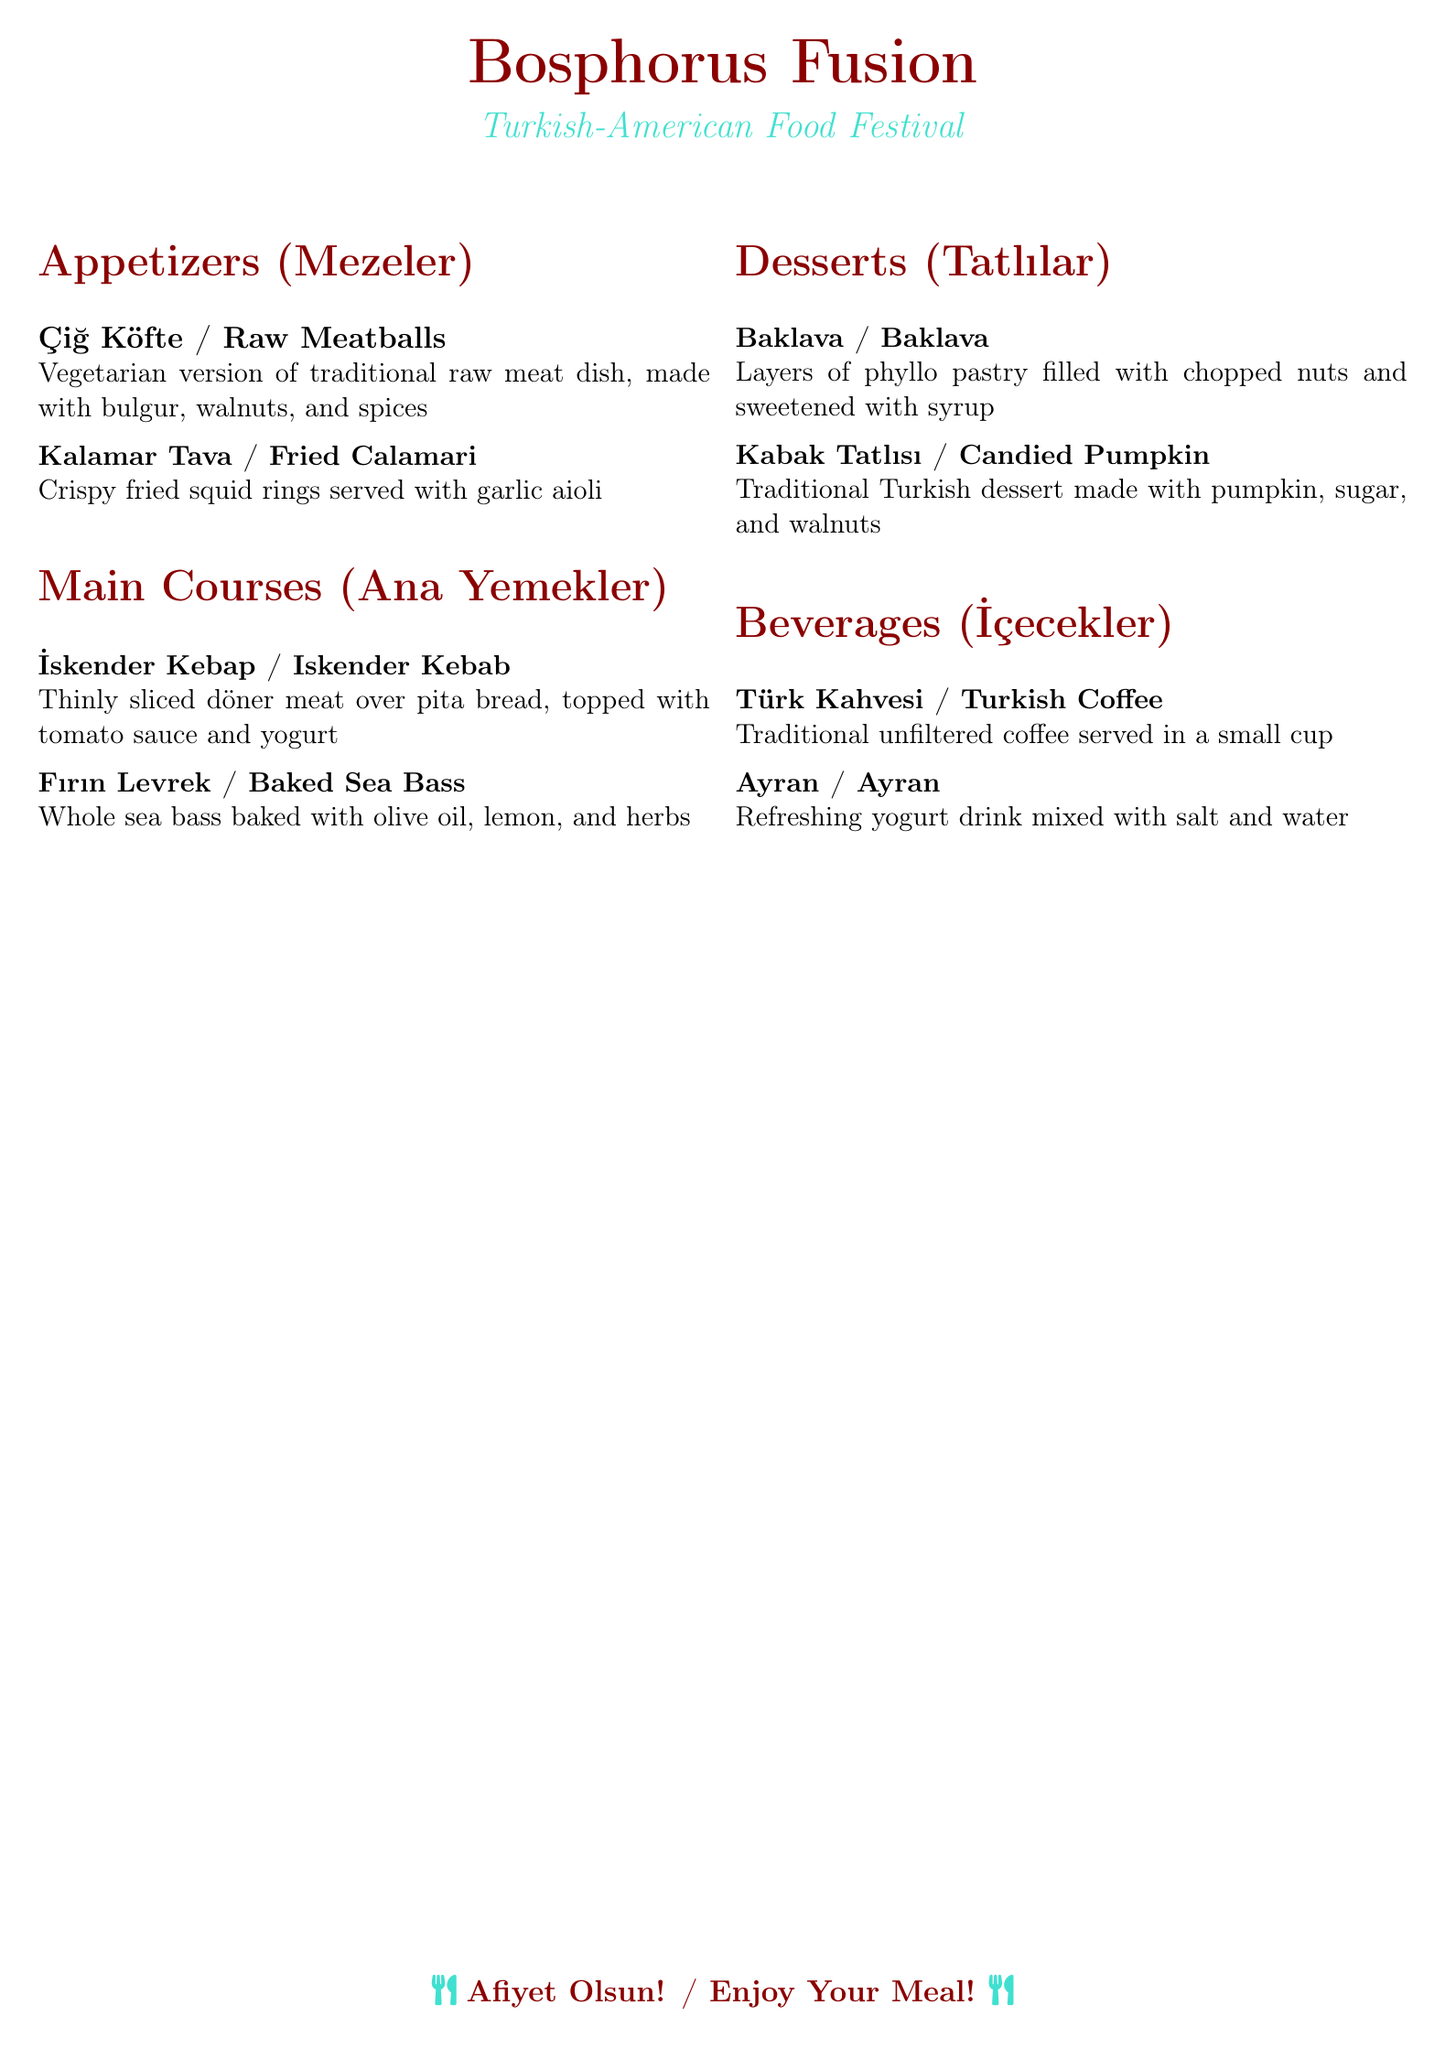What is the name of the festival? The name of the festival is prominently displayed at the top of the menu.
Answer: Bosphorus Fusion What type of dessert is Baklava? The dessert Baklava is listed under the Desserts section of the menu.
Answer: Baklava How many main courses are listed? By counting the items in the Main Courses section, we can determine the total.
Answer: 2 What is served with the Kalamar Tava? The menu specifies what accompanies the Fried Calamari.
Answer: garlic aioli What is the main ingredient in Kabak Tatlısı? The menu provides the primary ingredient used in this traditional dessert.
Answer: pumpkin What is the beverage section titled in Turkish? The document provides a specific title for the beverages section in Turkish.
Answer: İçecekler What type of fish is featured in Fırın Levrek? The name of the fish in the Baked Sea Bass dish can be found in the Main Courses section.
Answer: sea bass What is the main flavor in Türk Kahvesi? The menu highlights that the coffee is prepared in a specific manner.
Answer: unfiltered Which appetizer is vegetarian? The menu clearly states which appetizer has a vegetarian version.
Answer: Çiğ Köfte 